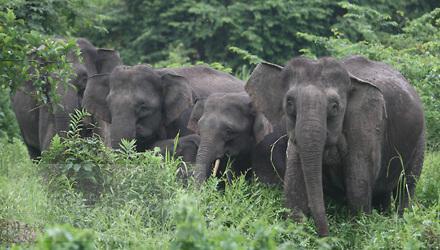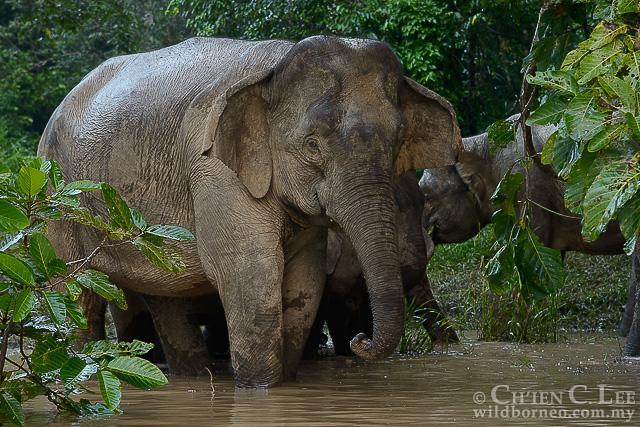The first image is the image on the left, the second image is the image on the right. For the images shown, is this caption "Three elephants in total." true? Answer yes or no. No. The first image is the image on the left, the second image is the image on the right. Given the left and right images, does the statement "One image shows an elephant with large tusks." hold true? Answer yes or no. No. 